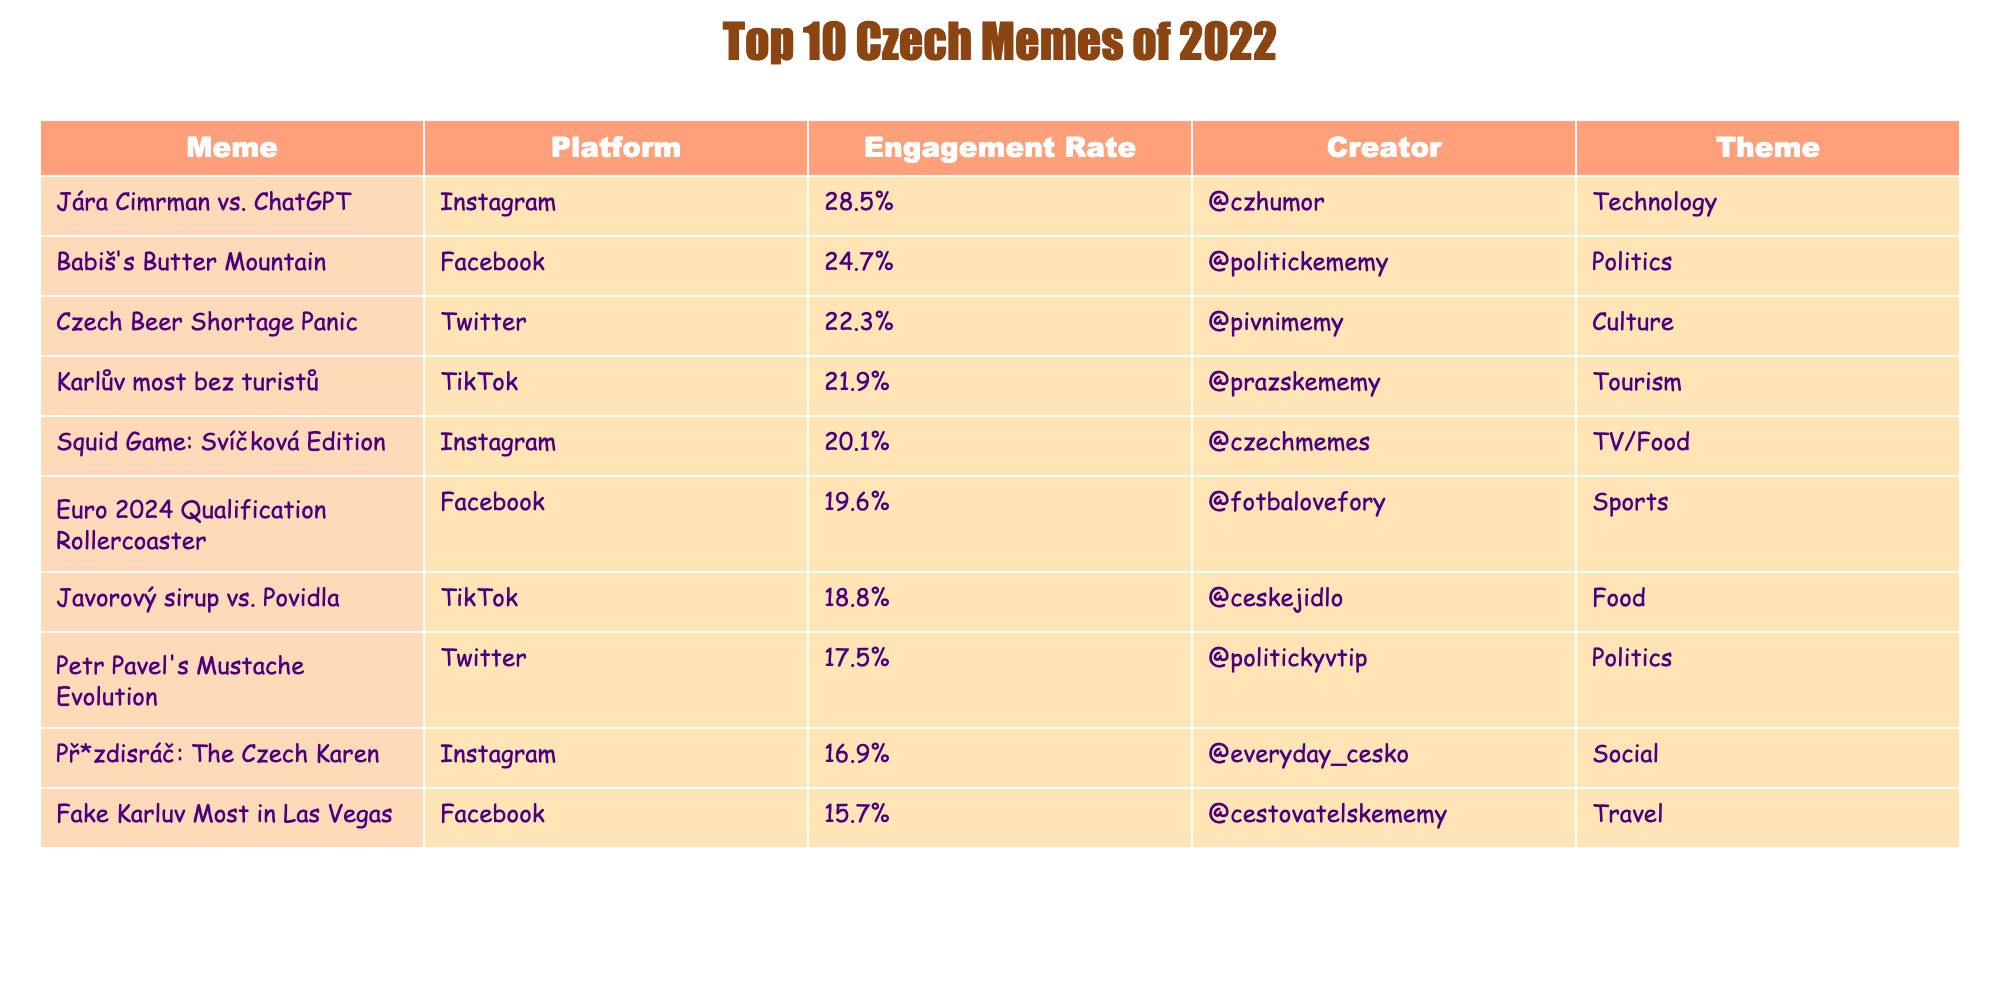What's the meme with the highest engagement rate? "Jára Cimrman vs. ChatGPT" has the highest engagement rate of 28.5% based on the table.
Answer: "Jára Cimrman vs. ChatGPT" What platform hosted the meme about the Czech beer shortage? The meme titled "Czech Beer Shortage Panic" was posted on Twitter.
Answer: Twitter Which meme was created by @politickememy? The meme called "Babiš's Butter Mountain" was created by @politickememy, as seen in the table.
Answer: "Babiš's Butter Mountain" What is the average engagement rate of the top three memes? The engagement rates for the top three memes are 28.5%, 24.7%, and 22.3%. The average is (28.5 + 24.7 + 22.3) / 3 = 25.17%.
Answer: 25.17% Is there a meme related to tourism in this table? Yes, "Karlův most bez turistů" is related to tourism and appears in the table.
Answer: Yes Which two memes have a political theme? The memes "Babiš's Butter Mountain" and "Petr Pavel's Mustache Evolution" both have a political theme according to the table.
Answer: 2 Calculate the difference in engagement rates between the highest and lowest ranked memes. The highest engagement rate is 28.5% for "Jára Cimrman vs. ChatGPT" and the lowest is 15.7% for "Fake Karluv Most in Las Vegas". The difference is 28.5% - 15.7% = 12.8%.
Answer: 12.8% How many memes in the table have an engagement rate above 20%? The table indicates that the following memes exceed 20% engagement: "Jára Cimrman vs. ChatGPT", "Babiš's Butter Mountain", "Czech Beer Shortage Panic", and "Karlův most bez turistů", totaling 4 memes.
Answer: 4 Which meme could be categorized under food and has an engagement rate below 20%? "Javorový sirup vs. Povidla" is categorized under food and has an engagement rate of 18.8%, which is below 20%.
Answer: "Javorový sirup vs. Povidla" What is the total engagement rate of all the listed memes? Summing the engagement rates: 28.5 + 24.7 + 22.3 + 21.9 + 20.1 + 19.6 + 18.8 + 17.5 + 16.9 + 15.7 =  205.1%. This is the total engagement rate of all memes in the table.
Answer: 205.1% 